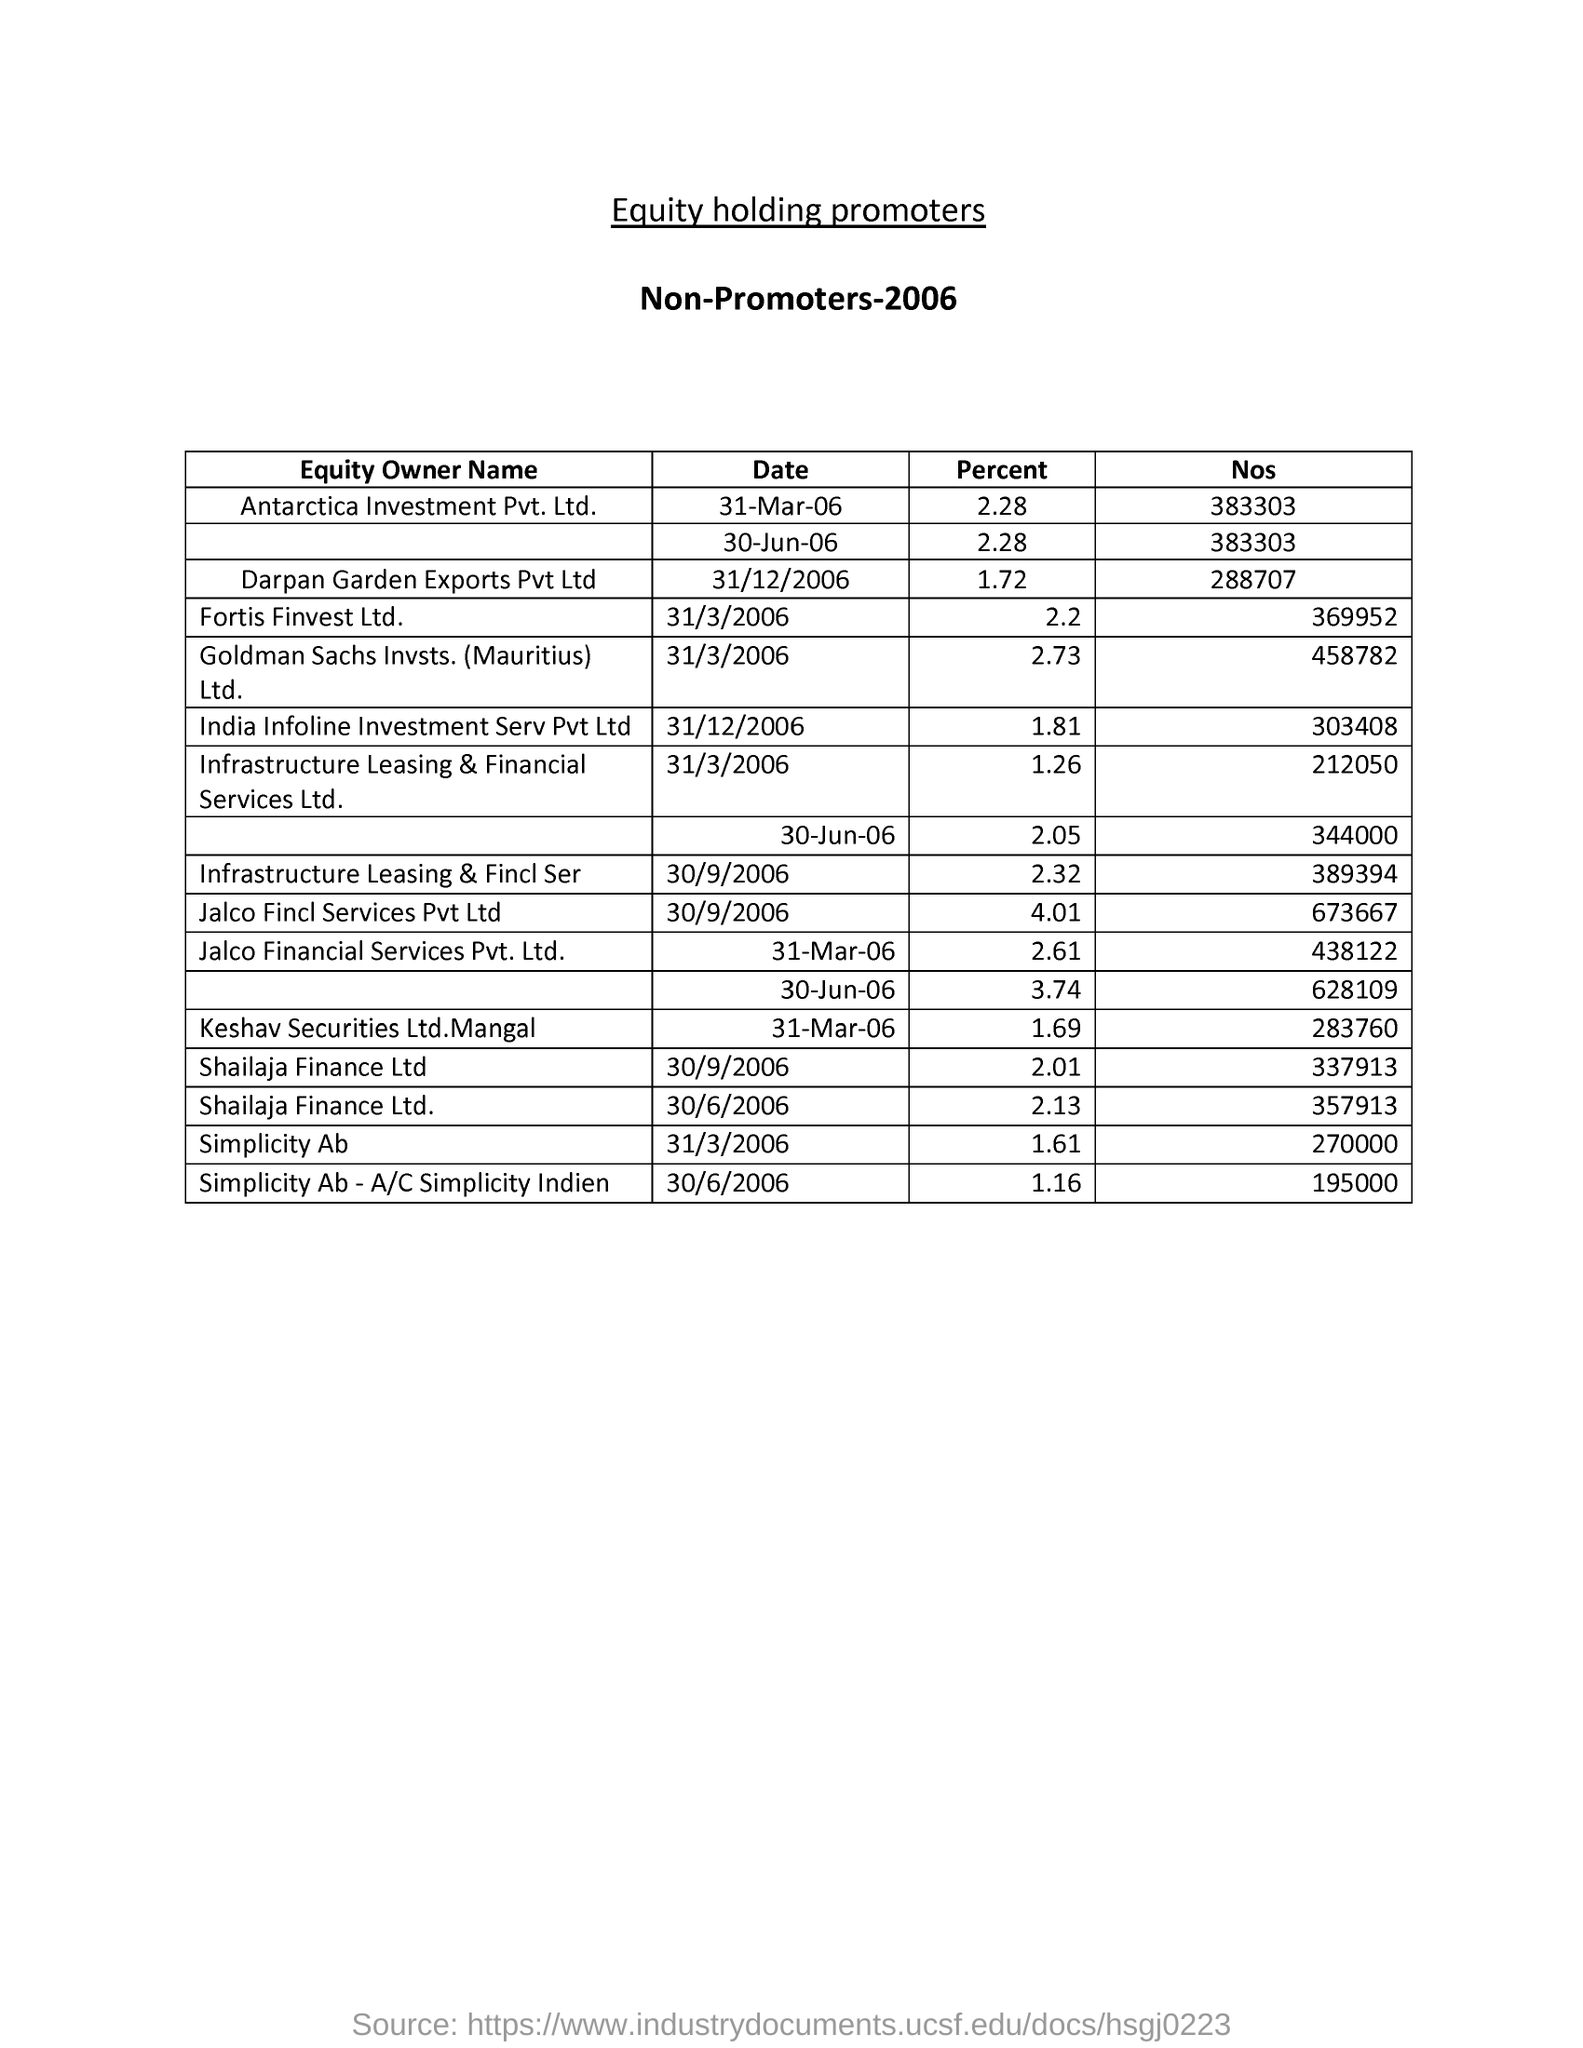Outline some significant characteristics in this image. On March 31, 2006, Simplicity Ab had a percentage of 1.61. 